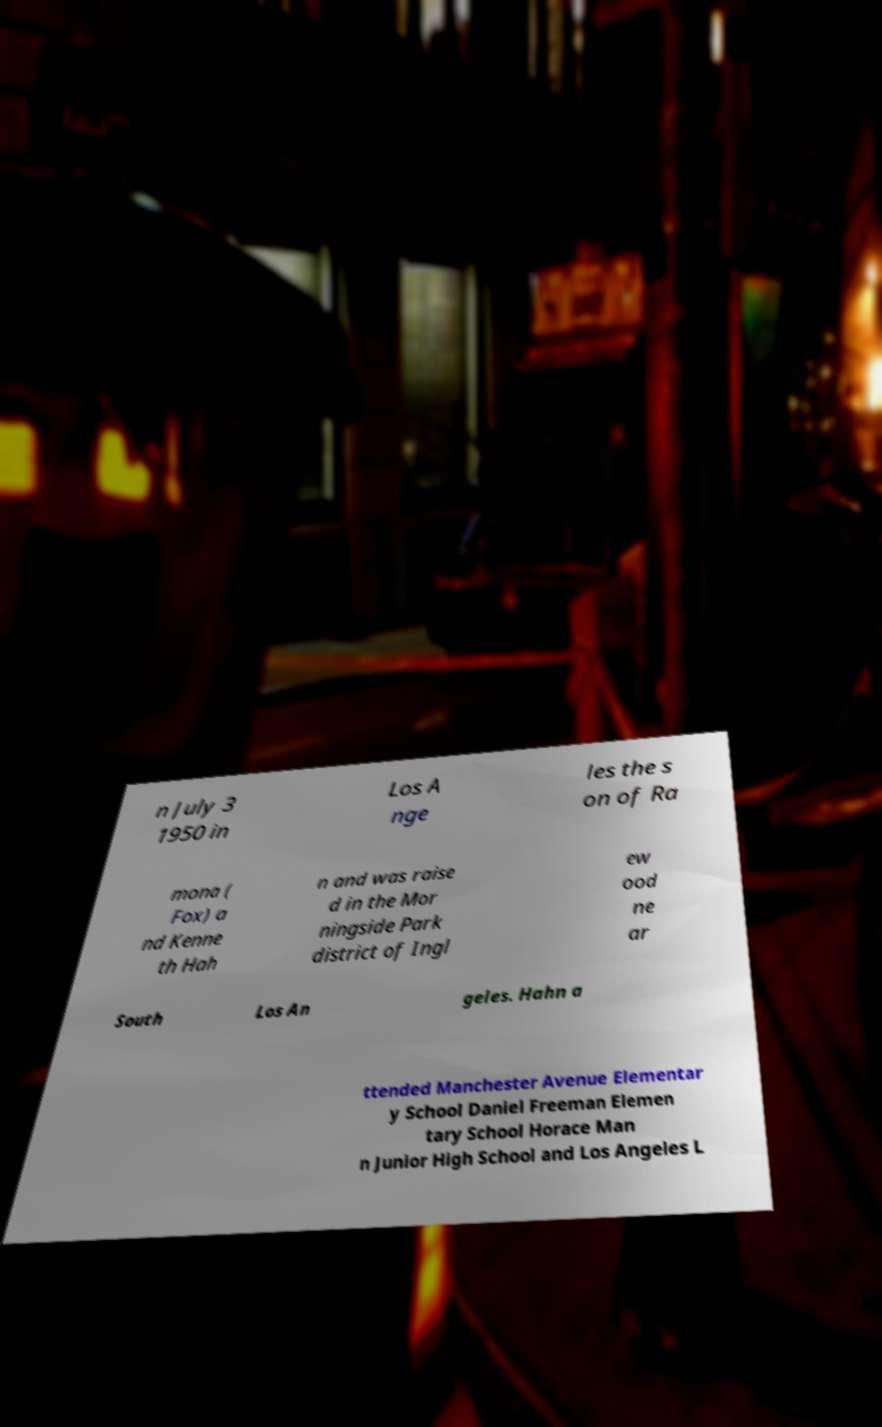Could you assist in decoding the text presented in this image and type it out clearly? n July 3 1950 in Los A nge les the s on of Ra mona ( Fox) a nd Kenne th Hah n and was raise d in the Mor ningside Park district of Ingl ew ood ne ar South Los An geles. Hahn a ttended Manchester Avenue Elementar y School Daniel Freeman Elemen tary School Horace Man n Junior High School and Los Angeles L 